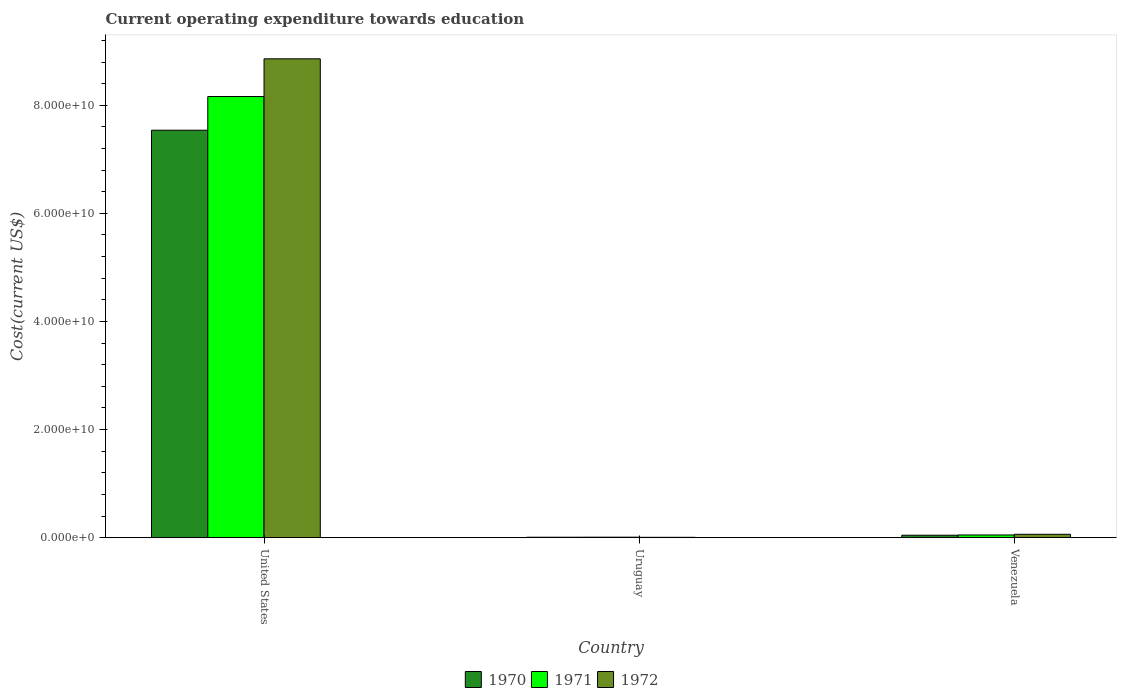How many different coloured bars are there?
Keep it short and to the point. 3. How many groups of bars are there?
Keep it short and to the point. 3. Are the number of bars per tick equal to the number of legend labels?
Offer a terse response. Yes. Are the number of bars on each tick of the X-axis equal?
Provide a short and direct response. Yes. What is the label of the 3rd group of bars from the left?
Give a very brief answer. Venezuela. What is the expenditure towards education in 1970 in United States?
Give a very brief answer. 7.54e+1. Across all countries, what is the maximum expenditure towards education in 1971?
Provide a short and direct response. 8.16e+1. Across all countries, what is the minimum expenditure towards education in 1972?
Provide a succinct answer. 7.10e+07. In which country was the expenditure towards education in 1971 maximum?
Make the answer very short. United States. In which country was the expenditure towards education in 1972 minimum?
Offer a terse response. Uruguay. What is the total expenditure towards education in 1970 in the graph?
Offer a terse response. 7.59e+1. What is the difference between the expenditure towards education in 1970 in United States and that in Uruguay?
Give a very brief answer. 7.53e+1. What is the difference between the expenditure towards education in 1970 in United States and the expenditure towards education in 1971 in Uruguay?
Offer a very short reply. 7.53e+1. What is the average expenditure towards education in 1971 per country?
Give a very brief answer. 2.74e+1. What is the difference between the expenditure towards education of/in 1970 and expenditure towards education of/in 1972 in Venezuela?
Your answer should be compact. -1.73e+08. What is the ratio of the expenditure towards education in 1972 in United States to that in Venezuela?
Provide a succinct answer. 139.92. What is the difference between the highest and the second highest expenditure towards education in 1972?
Your answer should be very brief. 8.80e+1. What is the difference between the highest and the lowest expenditure towards education in 1971?
Give a very brief answer. 8.15e+1. In how many countries, is the expenditure towards education in 1970 greater than the average expenditure towards education in 1970 taken over all countries?
Offer a very short reply. 1. Is the sum of the expenditure towards education in 1971 in United States and Uruguay greater than the maximum expenditure towards education in 1970 across all countries?
Your answer should be compact. Yes. What does the 3rd bar from the left in United States represents?
Give a very brief answer. 1972. What does the 2nd bar from the right in Venezuela represents?
Keep it short and to the point. 1971. How many bars are there?
Provide a succinct answer. 9. What is the difference between two consecutive major ticks on the Y-axis?
Provide a short and direct response. 2.00e+1. Does the graph contain any zero values?
Keep it short and to the point. No. Where does the legend appear in the graph?
Give a very brief answer. Bottom center. How are the legend labels stacked?
Your answer should be compact. Horizontal. What is the title of the graph?
Provide a short and direct response. Current operating expenditure towards education. Does "2003" appear as one of the legend labels in the graph?
Your answer should be very brief. No. What is the label or title of the Y-axis?
Provide a short and direct response. Cost(current US$). What is the Cost(current US$) in 1970 in United States?
Give a very brief answer. 7.54e+1. What is the Cost(current US$) of 1971 in United States?
Keep it short and to the point. 8.16e+1. What is the Cost(current US$) in 1972 in United States?
Offer a terse response. 8.86e+1. What is the Cost(current US$) of 1970 in Uruguay?
Keep it short and to the point. 8.80e+07. What is the Cost(current US$) of 1971 in Uruguay?
Provide a short and direct response. 9.76e+07. What is the Cost(current US$) in 1972 in Uruguay?
Offer a very short reply. 7.10e+07. What is the Cost(current US$) in 1970 in Venezuela?
Offer a very short reply. 4.60e+08. What is the Cost(current US$) in 1971 in Venezuela?
Provide a short and direct response. 5.08e+08. What is the Cost(current US$) in 1972 in Venezuela?
Provide a succinct answer. 6.33e+08. Across all countries, what is the maximum Cost(current US$) of 1970?
Offer a very short reply. 7.54e+1. Across all countries, what is the maximum Cost(current US$) in 1971?
Make the answer very short. 8.16e+1. Across all countries, what is the maximum Cost(current US$) in 1972?
Ensure brevity in your answer.  8.86e+1. Across all countries, what is the minimum Cost(current US$) in 1970?
Offer a very short reply. 8.80e+07. Across all countries, what is the minimum Cost(current US$) of 1971?
Offer a very short reply. 9.76e+07. Across all countries, what is the minimum Cost(current US$) of 1972?
Offer a terse response. 7.10e+07. What is the total Cost(current US$) in 1970 in the graph?
Give a very brief answer. 7.59e+1. What is the total Cost(current US$) of 1971 in the graph?
Offer a very short reply. 8.22e+1. What is the total Cost(current US$) of 1972 in the graph?
Offer a very short reply. 8.93e+1. What is the difference between the Cost(current US$) in 1970 in United States and that in Uruguay?
Offer a terse response. 7.53e+1. What is the difference between the Cost(current US$) of 1971 in United States and that in Uruguay?
Make the answer very short. 8.15e+1. What is the difference between the Cost(current US$) of 1972 in United States and that in Uruguay?
Your response must be concise. 8.85e+1. What is the difference between the Cost(current US$) in 1970 in United States and that in Venezuela?
Keep it short and to the point. 7.49e+1. What is the difference between the Cost(current US$) in 1971 in United States and that in Venezuela?
Keep it short and to the point. 8.11e+1. What is the difference between the Cost(current US$) of 1972 in United States and that in Venezuela?
Offer a terse response. 8.80e+1. What is the difference between the Cost(current US$) in 1970 in Uruguay and that in Venezuela?
Keep it short and to the point. -3.72e+08. What is the difference between the Cost(current US$) of 1971 in Uruguay and that in Venezuela?
Offer a very short reply. -4.11e+08. What is the difference between the Cost(current US$) of 1972 in Uruguay and that in Venezuela?
Make the answer very short. -5.62e+08. What is the difference between the Cost(current US$) in 1970 in United States and the Cost(current US$) in 1971 in Uruguay?
Provide a succinct answer. 7.53e+1. What is the difference between the Cost(current US$) in 1970 in United States and the Cost(current US$) in 1972 in Uruguay?
Keep it short and to the point. 7.53e+1. What is the difference between the Cost(current US$) in 1971 in United States and the Cost(current US$) in 1972 in Uruguay?
Keep it short and to the point. 8.15e+1. What is the difference between the Cost(current US$) of 1970 in United States and the Cost(current US$) of 1971 in Venezuela?
Your answer should be very brief. 7.49e+1. What is the difference between the Cost(current US$) of 1970 in United States and the Cost(current US$) of 1972 in Venezuela?
Provide a succinct answer. 7.47e+1. What is the difference between the Cost(current US$) of 1971 in United States and the Cost(current US$) of 1972 in Venezuela?
Provide a succinct answer. 8.10e+1. What is the difference between the Cost(current US$) of 1970 in Uruguay and the Cost(current US$) of 1971 in Venezuela?
Provide a short and direct response. -4.20e+08. What is the difference between the Cost(current US$) in 1970 in Uruguay and the Cost(current US$) in 1972 in Venezuela?
Your response must be concise. -5.45e+08. What is the difference between the Cost(current US$) in 1971 in Uruguay and the Cost(current US$) in 1972 in Venezuela?
Offer a terse response. -5.36e+08. What is the average Cost(current US$) of 1970 per country?
Keep it short and to the point. 2.53e+1. What is the average Cost(current US$) of 1971 per country?
Your answer should be very brief. 2.74e+1. What is the average Cost(current US$) of 1972 per country?
Provide a succinct answer. 2.98e+1. What is the difference between the Cost(current US$) of 1970 and Cost(current US$) of 1971 in United States?
Your answer should be compact. -6.23e+09. What is the difference between the Cost(current US$) in 1970 and Cost(current US$) in 1972 in United States?
Offer a terse response. -1.32e+1. What is the difference between the Cost(current US$) of 1971 and Cost(current US$) of 1972 in United States?
Offer a terse response. -6.98e+09. What is the difference between the Cost(current US$) of 1970 and Cost(current US$) of 1971 in Uruguay?
Provide a short and direct response. -9.58e+06. What is the difference between the Cost(current US$) of 1970 and Cost(current US$) of 1972 in Uruguay?
Offer a terse response. 1.70e+07. What is the difference between the Cost(current US$) of 1971 and Cost(current US$) of 1972 in Uruguay?
Provide a succinct answer. 2.65e+07. What is the difference between the Cost(current US$) in 1970 and Cost(current US$) in 1971 in Venezuela?
Your answer should be compact. -4.79e+07. What is the difference between the Cost(current US$) in 1970 and Cost(current US$) in 1972 in Venezuela?
Offer a terse response. -1.73e+08. What is the difference between the Cost(current US$) of 1971 and Cost(current US$) of 1972 in Venezuela?
Keep it short and to the point. -1.25e+08. What is the ratio of the Cost(current US$) in 1970 in United States to that in Uruguay?
Your response must be concise. 856.91. What is the ratio of the Cost(current US$) in 1971 in United States to that in Uruguay?
Ensure brevity in your answer.  836.62. What is the ratio of the Cost(current US$) in 1972 in United States to that in Uruguay?
Your answer should be compact. 1247.56. What is the ratio of the Cost(current US$) in 1970 in United States to that in Venezuela?
Offer a terse response. 163.77. What is the ratio of the Cost(current US$) of 1971 in United States to that in Venezuela?
Ensure brevity in your answer.  160.61. What is the ratio of the Cost(current US$) of 1972 in United States to that in Venezuela?
Offer a very short reply. 139.92. What is the ratio of the Cost(current US$) of 1970 in Uruguay to that in Venezuela?
Provide a succinct answer. 0.19. What is the ratio of the Cost(current US$) in 1971 in Uruguay to that in Venezuela?
Your answer should be compact. 0.19. What is the ratio of the Cost(current US$) of 1972 in Uruguay to that in Venezuela?
Your response must be concise. 0.11. What is the difference between the highest and the second highest Cost(current US$) of 1970?
Ensure brevity in your answer.  7.49e+1. What is the difference between the highest and the second highest Cost(current US$) of 1971?
Your response must be concise. 8.11e+1. What is the difference between the highest and the second highest Cost(current US$) in 1972?
Your answer should be compact. 8.80e+1. What is the difference between the highest and the lowest Cost(current US$) of 1970?
Ensure brevity in your answer.  7.53e+1. What is the difference between the highest and the lowest Cost(current US$) of 1971?
Ensure brevity in your answer.  8.15e+1. What is the difference between the highest and the lowest Cost(current US$) of 1972?
Your answer should be compact. 8.85e+1. 